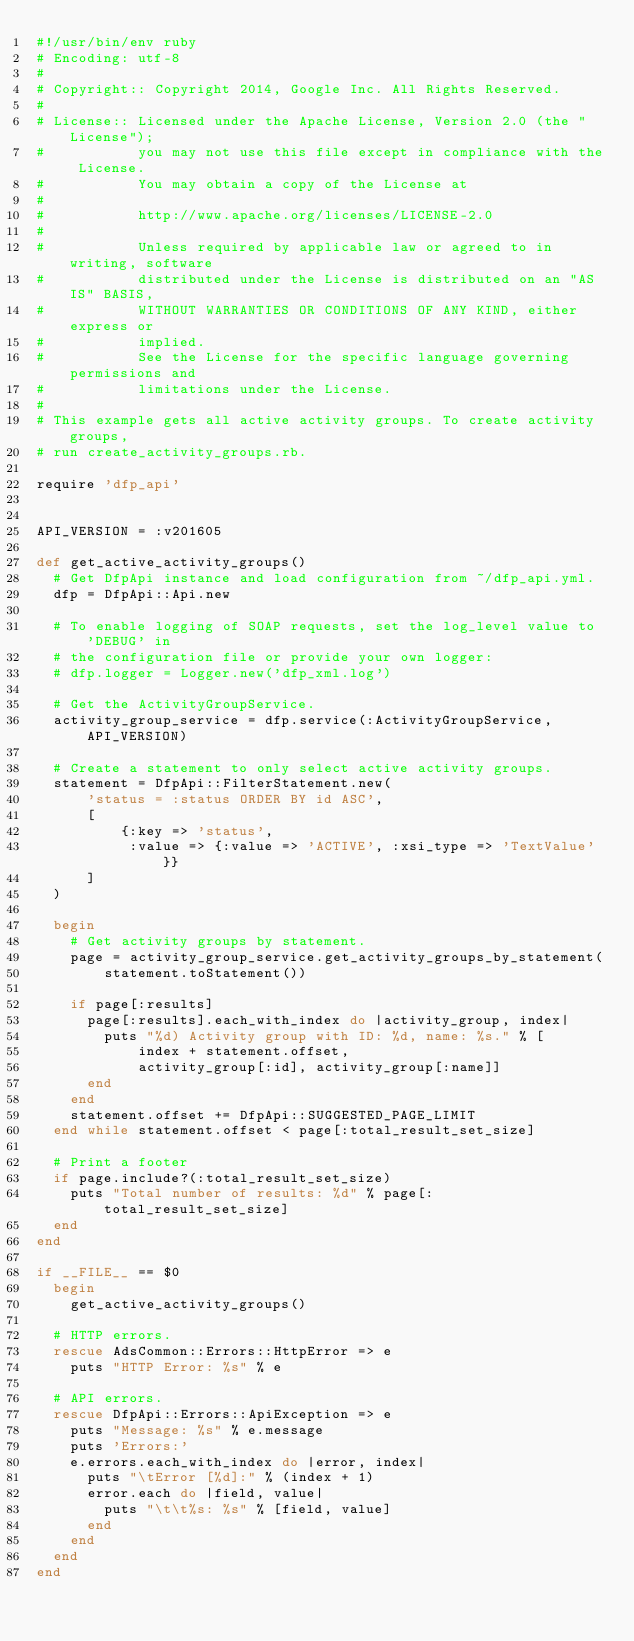<code> <loc_0><loc_0><loc_500><loc_500><_Ruby_>#!/usr/bin/env ruby
# Encoding: utf-8
#
# Copyright:: Copyright 2014, Google Inc. All Rights Reserved.
#
# License:: Licensed under the Apache License, Version 2.0 (the "License");
#           you may not use this file except in compliance with the License.
#           You may obtain a copy of the License at
#
#           http://www.apache.org/licenses/LICENSE-2.0
#
#           Unless required by applicable law or agreed to in writing, software
#           distributed under the License is distributed on an "AS IS" BASIS,
#           WITHOUT WARRANTIES OR CONDITIONS OF ANY KIND, either express or
#           implied.
#           See the License for the specific language governing permissions and
#           limitations under the License.
#
# This example gets all active activity groups. To create activity groups,
# run create_activity_groups.rb.

require 'dfp_api'


API_VERSION = :v201605

def get_active_activity_groups()
  # Get DfpApi instance and load configuration from ~/dfp_api.yml.
  dfp = DfpApi::Api.new

  # To enable logging of SOAP requests, set the log_level value to 'DEBUG' in
  # the configuration file or provide your own logger:
  # dfp.logger = Logger.new('dfp_xml.log')

  # Get the ActivityGroupService.
  activity_group_service = dfp.service(:ActivityGroupService, API_VERSION)

  # Create a statement to only select active activity groups.
  statement = DfpApi::FilterStatement.new(
      'status = :status ORDER BY id ASC',
      [
          {:key => 'status',
           :value => {:value => 'ACTIVE', :xsi_type => 'TextValue'}}
      ]
  )

  begin
    # Get activity groups by statement.
    page = activity_group_service.get_activity_groups_by_statement(
        statement.toStatement())

    if page[:results]
      page[:results].each_with_index do |activity_group, index|
        puts "%d) Activity group with ID: %d, name: %s." % [
            index + statement.offset,
            activity_group[:id], activity_group[:name]]
      end
    end
    statement.offset += DfpApi::SUGGESTED_PAGE_LIMIT
  end while statement.offset < page[:total_result_set_size]

  # Print a footer
  if page.include?(:total_result_set_size)
    puts "Total number of results: %d" % page[:total_result_set_size]
  end
end

if __FILE__ == $0
  begin
    get_active_activity_groups()

  # HTTP errors.
  rescue AdsCommon::Errors::HttpError => e
    puts "HTTP Error: %s" % e

  # API errors.
  rescue DfpApi::Errors::ApiException => e
    puts "Message: %s" % e.message
    puts 'Errors:'
    e.errors.each_with_index do |error, index|
      puts "\tError [%d]:" % (index + 1)
      error.each do |field, value|
        puts "\t\t%s: %s" % [field, value]
      end
    end
  end
end
</code> 